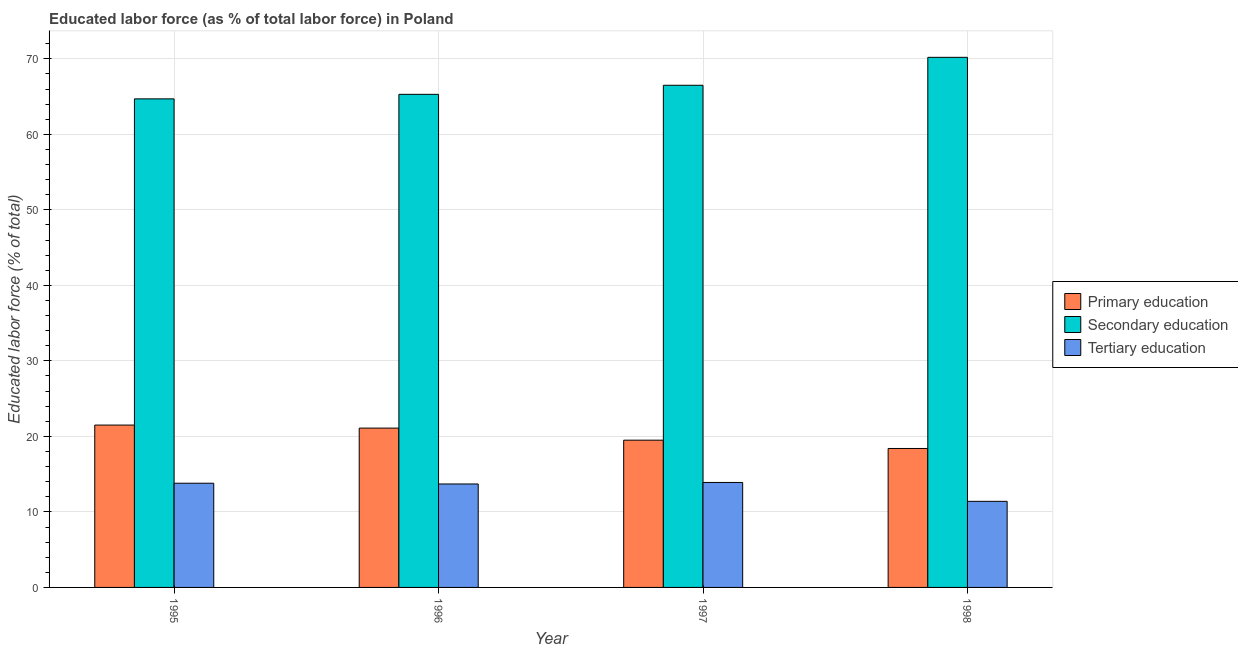How many different coloured bars are there?
Offer a very short reply. 3. Are the number of bars per tick equal to the number of legend labels?
Make the answer very short. Yes. Are the number of bars on each tick of the X-axis equal?
Offer a very short reply. Yes. How many bars are there on the 2nd tick from the right?
Provide a short and direct response. 3. What is the percentage of labor force who received primary education in 1998?
Offer a very short reply. 18.4. Across all years, what is the maximum percentage of labor force who received primary education?
Your response must be concise. 21.5. Across all years, what is the minimum percentage of labor force who received primary education?
Make the answer very short. 18.4. What is the total percentage of labor force who received secondary education in the graph?
Make the answer very short. 266.7. What is the difference between the percentage of labor force who received tertiary education in 1995 and that in 1998?
Keep it short and to the point. 2.4. What is the difference between the percentage of labor force who received primary education in 1996 and the percentage of labor force who received tertiary education in 1995?
Ensure brevity in your answer.  -0.4. What is the average percentage of labor force who received secondary education per year?
Your answer should be very brief. 66.67. In the year 1997, what is the difference between the percentage of labor force who received secondary education and percentage of labor force who received tertiary education?
Keep it short and to the point. 0. In how many years, is the percentage of labor force who received tertiary education greater than 16 %?
Keep it short and to the point. 0. What is the ratio of the percentage of labor force who received primary education in 1995 to that in 1996?
Your response must be concise. 1.02. What is the difference between the highest and the second highest percentage of labor force who received tertiary education?
Keep it short and to the point. 0.1. What is the difference between the highest and the lowest percentage of labor force who received primary education?
Make the answer very short. 3.1. In how many years, is the percentage of labor force who received tertiary education greater than the average percentage of labor force who received tertiary education taken over all years?
Your answer should be compact. 3. What does the 2nd bar from the left in 1995 represents?
Your response must be concise. Secondary education. Is it the case that in every year, the sum of the percentage of labor force who received primary education and percentage of labor force who received secondary education is greater than the percentage of labor force who received tertiary education?
Offer a terse response. Yes. What is the difference between two consecutive major ticks on the Y-axis?
Your answer should be very brief. 10. Are the values on the major ticks of Y-axis written in scientific E-notation?
Ensure brevity in your answer.  No. Does the graph contain any zero values?
Give a very brief answer. No. Where does the legend appear in the graph?
Your answer should be very brief. Center right. How many legend labels are there?
Make the answer very short. 3. How are the legend labels stacked?
Make the answer very short. Vertical. What is the title of the graph?
Your answer should be very brief. Educated labor force (as % of total labor force) in Poland. Does "Gaseous fuel" appear as one of the legend labels in the graph?
Ensure brevity in your answer.  No. What is the label or title of the Y-axis?
Your answer should be very brief. Educated labor force (% of total). What is the Educated labor force (% of total) in Primary education in 1995?
Make the answer very short. 21.5. What is the Educated labor force (% of total) of Secondary education in 1995?
Keep it short and to the point. 64.7. What is the Educated labor force (% of total) of Tertiary education in 1995?
Ensure brevity in your answer.  13.8. What is the Educated labor force (% of total) in Primary education in 1996?
Your answer should be very brief. 21.1. What is the Educated labor force (% of total) of Secondary education in 1996?
Offer a very short reply. 65.3. What is the Educated labor force (% of total) of Tertiary education in 1996?
Ensure brevity in your answer.  13.7. What is the Educated labor force (% of total) of Secondary education in 1997?
Your answer should be compact. 66.5. What is the Educated labor force (% of total) of Tertiary education in 1997?
Ensure brevity in your answer.  13.9. What is the Educated labor force (% of total) in Primary education in 1998?
Offer a terse response. 18.4. What is the Educated labor force (% of total) of Secondary education in 1998?
Ensure brevity in your answer.  70.2. What is the Educated labor force (% of total) of Tertiary education in 1998?
Ensure brevity in your answer.  11.4. Across all years, what is the maximum Educated labor force (% of total) of Secondary education?
Your answer should be very brief. 70.2. Across all years, what is the maximum Educated labor force (% of total) of Tertiary education?
Provide a succinct answer. 13.9. Across all years, what is the minimum Educated labor force (% of total) in Primary education?
Ensure brevity in your answer.  18.4. Across all years, what is the minimum Educated labor force (% of total) in Secondary education?
Make the answer very short. 64.7. Across all years, what is the minimum Educated labor force (% of total) of Tertiary education?
Give a very brief answer. 11.4. What is the total Educated labor force (% of total) of Primary education in the graph?
Provide a short and direct response. 80.5. What is the total Educated labor force (% of total) in Secondary education in the graph?
Offer a terse response. 266.7. What is the total Educated labor force (% of total) of Tertiary education in the graph?
Give a very brief answer. 52.8. What is the difference between the Educated labor force (% of total) of Primary education in 1995 and that in 1996?
Your response must be concise. 0.4. What is the difference between the Educated labor force (% of total) of Secondary education in 1995 and that in 1996?
Ensure brevity in your answer.  -0.6. What is the difference between the Educated labor force (% of total) of Tertiary education in 1995 and that in 1996?
Provide a short and direct response. 0.1. What is the difference between the Educated labor force (% of total) of Primary education in 1995 and that in 1997?
Your answer should be very brief. 2. What is the difference between the Educated labor force (% of total) of Tertiary education in 1995 and that in 1997?
Offer a very short reply. -0.1. What is the difference between the Educated labor force (% of total) of Primary education in 1996 and that in 1997?
Offer a very short reply. 1.6. What is the difference between the Educated labor force (% of total) in Secondary education in 1996 and that in 1997?
Your response must be concise. -1.2. What is the difference between the Educated labor force (% of total) in Primary education in 1996 and that in 1998?
Give a very brief answer. 2.7. What is the difference between the Educated labor force (% of total) of Primary education in 1995 and the Educated labor force (% of total) of Secondary education in 1996?
Provide a succinct answer. -43.8. What is the difference between the Educated labor force (% of total) in Secondary education in 1995 and the Educated labor force (% of total) in Tertiary education in 1996?
Keep it short and to the point. 51. What is the difference between the Educated labor force (% of total) in Primary education in 1995 and the Educated labor force (% of total) in Secondary education in 1997?
Provide a short and direct response. -45. What is the difference between the Educated labor force (% of total) in Primary education in 1995 and the Educated labor force (% of total) in Tertiary education in 1997?
Your answer should be compact. 7.6. What is the difference between the Educated labor force (% of total) of Secondary education in 1995 and the Educated labor force (% of total) of Tertiary education in 1997?
Provide a short and direct response. 50.8. What is the difference between the Educated labor force (% of total) of Primary education in 1995 and the Educated labor force (% of total) of Secondary education in 1998?
Provide a short and direct response. -48.7. What is the difference between the Educated labor force (% of total) of Primary education in 1995 and the Educated labor force (% of total) of Tertiary education in 1998?
Make the answer very short. 10.1. What is the difference between the Educated labor force (% of total) in Secondary education in 1995 and the Educated labor force (% of total) in Tertiary education in 1998?
Offer a very short reply. 53.3. What is the difference between the Educated labor force (% of total) in Primary education in 1996 and the Educated labor force (% of total) in Secondary education in 1997?
Make the answer very short. -45.4. What is the difference between the Educated labor force (% of total) of Secondary education in 1996 and the Educated labor force (% of total) of Tertiary education in 1997?
Offer a terse response. 51.4. What is the difference between the Educated labor force (% of total) of Primary education in 1996 and the Educated labor force (% of total) of Secondary education in 1998?
Keep it short and to the point. -49.1. What is the difference between the Educated labor force (% of total) in Secondary education in 1996 and the Educated labor force (% of total) in Tertiary education in 1998?
Offer a very short reply. 53.9. What is the difference between the Educated labor force (% of total) in Primary education in 1997 and the Educated labor force (% of total) in Secondary education in 1998?
Offer a terse response. -50.7. What is the difference between the Educated labor force (% of total) of Secondary education in 1997 and the Educated labor force (% of total) of Tertiary education in 1998?
Provide a succinct answer. 55.1. What is the average Educated labor force (% of total) in Primary education per year?
Offer a terse response. 20.12. What is the average Educated labor force (% of total) of Secondary education per year?
Provide a short and direct response. 66.67. What is the average Educated labor force (% of total) of Tertiary education per year?
Your answer should be very brief. 13.2. In the year 1995, what is the difference between the Educated labor force (% of total) in Primary education and Educated labor force (% of total) in Secondary education?
Your response must be concise. -43.2. In the year 1995, what is the difference between the Educated labor force (% of total) in Primary education and Educated labor force (% of total) in Tertiary education?
Your response must be concise. 7.7. In the year 1995, what is the difference between the Educated labor force (% of total) in Secondary education and Educated labor force (% of total) in Tertiary education?
Your response must be concise. 50.9. In the year 1996, what is the difference between the Educated labor force (% of total) in Primary education and Educated labor force (% of total) in Secondary education?
Keep it short and to the point. -44.2. In the year 1996, what is the difference between the Educated labor force (% of total) of Primary education and Educated labor force (% of total) of Tertiary education?
Make the answer very short. 7.4. In the year 1996, what is the difference between the Educated labor force (% of total) of Secondary education and Educated labor force (% of total) of Tertiary education?
Ensure brevity in your answer.  51.6. In the year 1997, what is the difference between the Educated labor force (% of total) in Primary education and Educated labor force (% of total) in Secondary education?
Offer a terse response. -47. In the year 1997, what is the difference between the Educated labor force (% of total) in Secondary education and Educated labor force (% of total) in Tertiary education?
Your answer should be very brief. 52.6. In the year 1998, what is the difference between the Educated labor force (% of total) in Primary education and Educated labor force (% of total) in Secondary education?
Keep it short and to the point. -51.8. In the year 1998, what is the difference between the Educated labor force (% of total) in Secondary education and Educated labor force (% of total) in Tertiary education?
Give a very brief answer. 58.8. What is the ratio of the Educated labor force (% of total) in Primary education in 1995 to that in 1996?
Ensure brevity in your answer.  1.02. What is the ratio of the Educated labor force (% of total) of Secondary education in 1995 to that in 1996?
Provide a succinct answer. 0.99. What is the ratio of the Educated labor force (% of total) in Tertiary education in 1995 to that in 1996?
Provide a short and direct response. 1.01. What is the ratio of the Educated labor force (% of total) in Primary education in 1995 to that in 1997?
Keep it short and to the point. 1.1. What is the ratio of the Educated labor force (% of total) in Secondary education in 1995 to that in 1997?
Offer a very short reply. 0.97. What is the ratio of the Educated labor force (% of total) in Primary education in 1995 to that in 1998?
Offer a very short reply. 1.17. What is the ratio of the Educated labor force (% of total) in Secondary education in 1995 to that in 1998?
Give a very brief answer. 0.92. What is the ratio of the Educated labor force (% of total) of Tertiary education in 1995 to that in 1998?
Give a very brief answer. 1.21. What is the ratio of the Educated labor force (% of total) in Primary education in 1996 to that in 1997?
Give a very brief answer. 1.08. What is the ratio of the Educated labor force (% of total) in Tertiary education in 1996 to that in 1997?
Offer a terse response. 0.99. What is the ratio of the Educated labor force (% of total) of Primary education in 1996 to that in 1998?
Provide a short and direct response. 1.15. What is the ratio of the Educated labor force (% of total) of Secondary education in 1996 to that in 1998?
Keep it short and to the point. 0.93. What is the ratio of the Educated labor force (% of total) of Tertiary education in 1996 to that in 1998?
Keep it short and to the point. 1.2. What is the ratio of the Educated labor force (% of total) in Primary education in 1997 to that in 1998?
Offer a very short reply. 1.06. What is the ratio of the Educated labor force (% of total) in Secondary education in 1997 to that in 1998?
Provide a short and direct response. 0.95. What is the ratio of the Educated labor force (% of total) in Tertiary education in 1997 to that in 1998?
Provide a succinct answer. 1.22. What is the difference between the highest and the second highest Educated labor force (% of total) of Primary education?
Your answer should be compact. 0.4. What is the difference between the highest and the lowest Educated labor force (% of total) of Secondary education?
Give a very brief answer. 5.5. What is the difference between the highest and the lowest Educated labor force (% of total) in Tertiary education?
Make the answer very short. 2.5. 